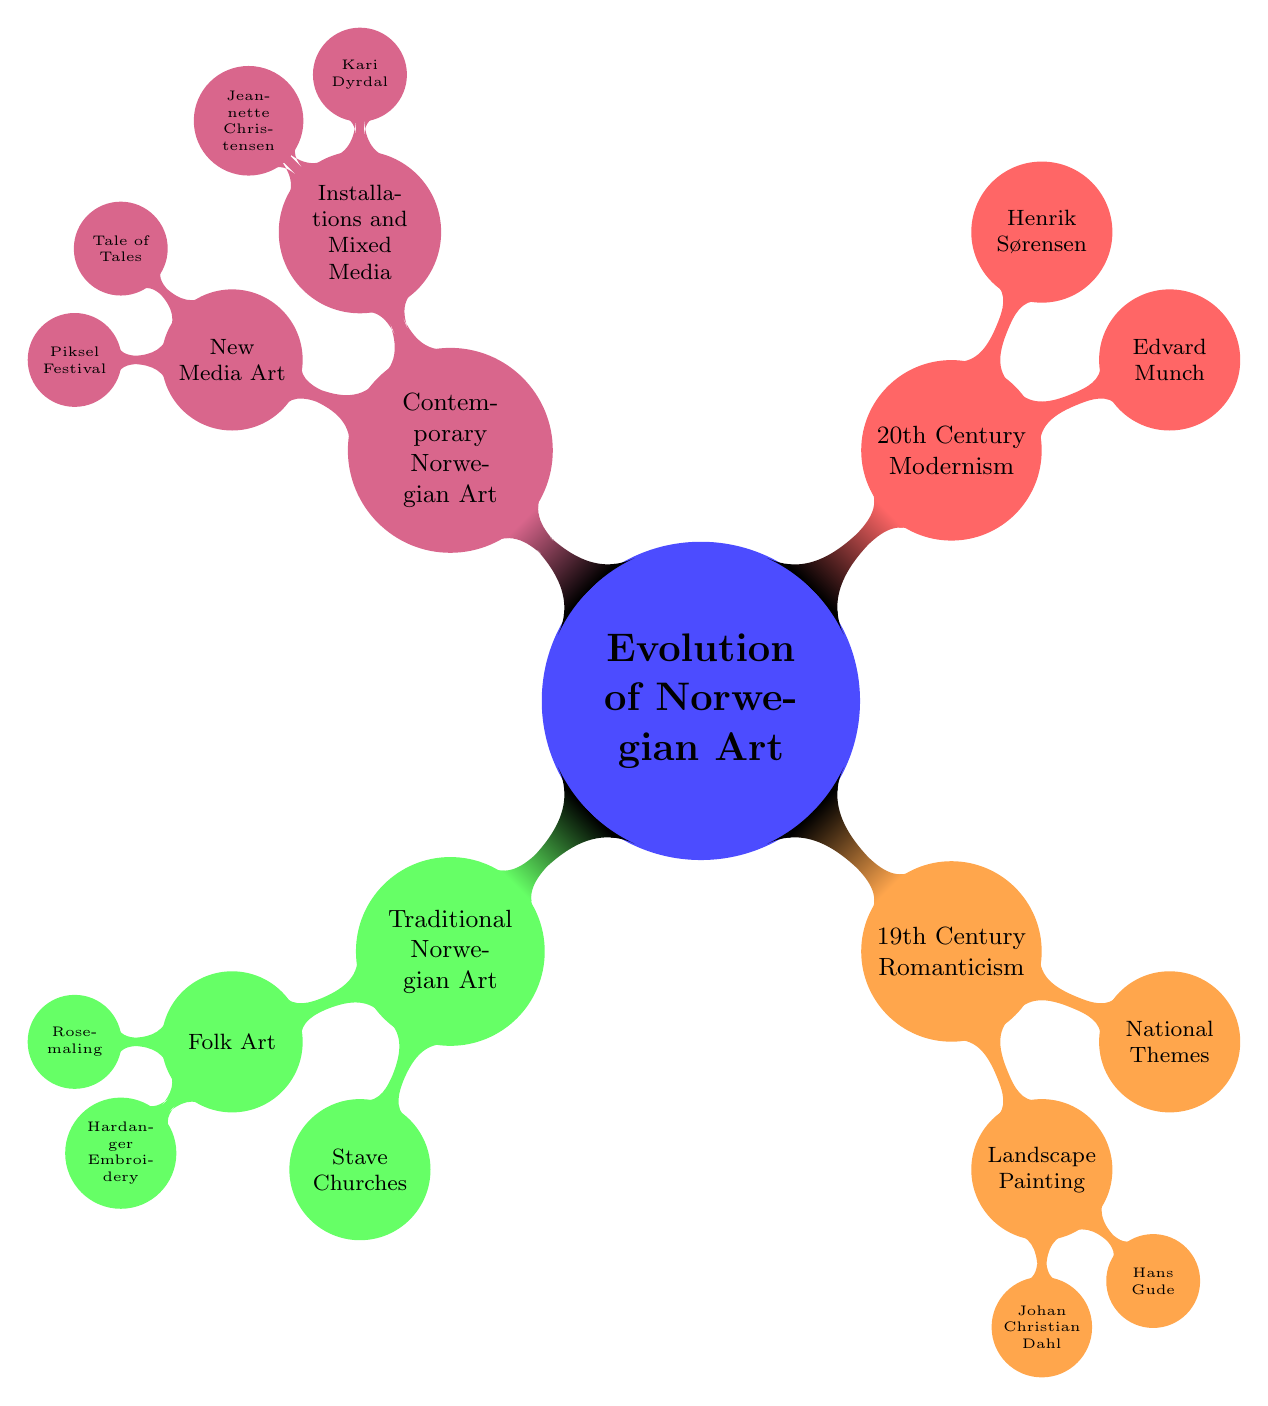What are the main categories of Norwegian art evolution presented in the diagram? The diagram shows four main categories: Traditional Norwegian Art, 19th Century Romanticism, 20th Century Modernism, and Contemporary Norwegian Art.
Answer: Traditional Norwegian Art, 19th Century Romanticism, 20th Century Modernism, Contemporary Norwegian Art How many subnodes are under Traditional Norwegian Art? Under Traditional Norwegian Art, there are two subnodes: Folk Art and Stave Churches. Thus, the total number of subnodes is 2.
Answer: 2 Who is considered the father of Norwegian landscape painting? The diagram lists Johan Christian Dahl as the father of Norwegian landscape painting.
Answer: Johan Christian Dahl Which art movement is associated with Edvard Munch? Edvard Munch is associated with the Expressionism art movement, according to the information provided in the diagram.
Answer: Expressionism What type of artwork does Kari Dyrdal create? The diagram indicates that Kari Dyrdal is a textile artist, integrating traditional methods with contemporary themes.
Answer: Textile artist What is the distinguishing feature of Stave Churches? The diagram states that Stave Churches are medieval wooden churches known for their intricate carvings.
Answer: Intricate carvings In what century did National Romanticism emerge in Norwegian art? The diagram categorizes National Romanticism under the 19th Century Romanticism node, indicating that it emerged in the 19th century.
Answer: 19th century How many artists are mentioned under Contemporary Norwegian Art, Installations, and Mixed Media? Under "Installations and Mixed Media," there are two artists mentioned: Kari Dyrdal and Jeannette Christensen. So, the total number is 2.
Answer: 2 Which festival focuses on electronic art and free technologies? According to the diagram, the Piksel Festival is noted for focusing on electronic art and free technologies.
Answer: Piksel Festival What element connects all categories of the diagram? The connective element linking all categories is their focus on the evolution of Norwegian art over time, from traditional roots to contemporary practices.
Answer: Norwegian art evolution 